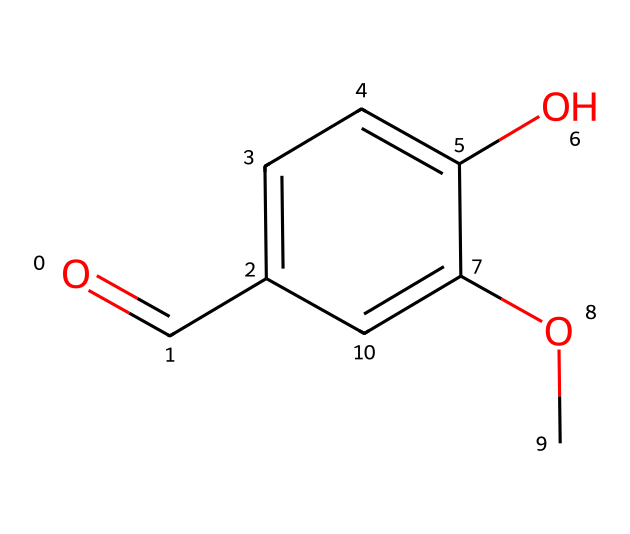What is the functional group present in vanillin? The chemical structure contains a carbonyl group (C=O) and an -OH (hydroxyl) group. The carbonyl group is characteristic of aldehydes.
Answer: aldehyde How many carbon atoms are in the vanillin structure? By examining the SMILES representation, we count a total of 8 carbon atoms (C) reflected in the molecular structure.
Answer: 8 What type of aromatic compound is vanillin? The presence of the benzene ring (c1ccc) indicates that vanillin is a phenolic compound.
Answer: phenolic Which part of the vanillin molecule contributes to its sweet smell? The combination of the aldehyde group (C=O) and the adjacent aromatic structure contributes to its characteristic sweet scent.
Answer: aldehyde How many oxygen atoms are present in the molecular structure of vanillin? The SMILES representation indicates two oxygen atoms: one in the carbonyl group and one in the hydroxyl group.
Answer: 2 Does vanillin exhibit properties characteristic of aldehydes? Yes, vanillin has a reactive carbonyl group typical of aldehydes, which can undergo reactions like oxidation.
Answer: yes 